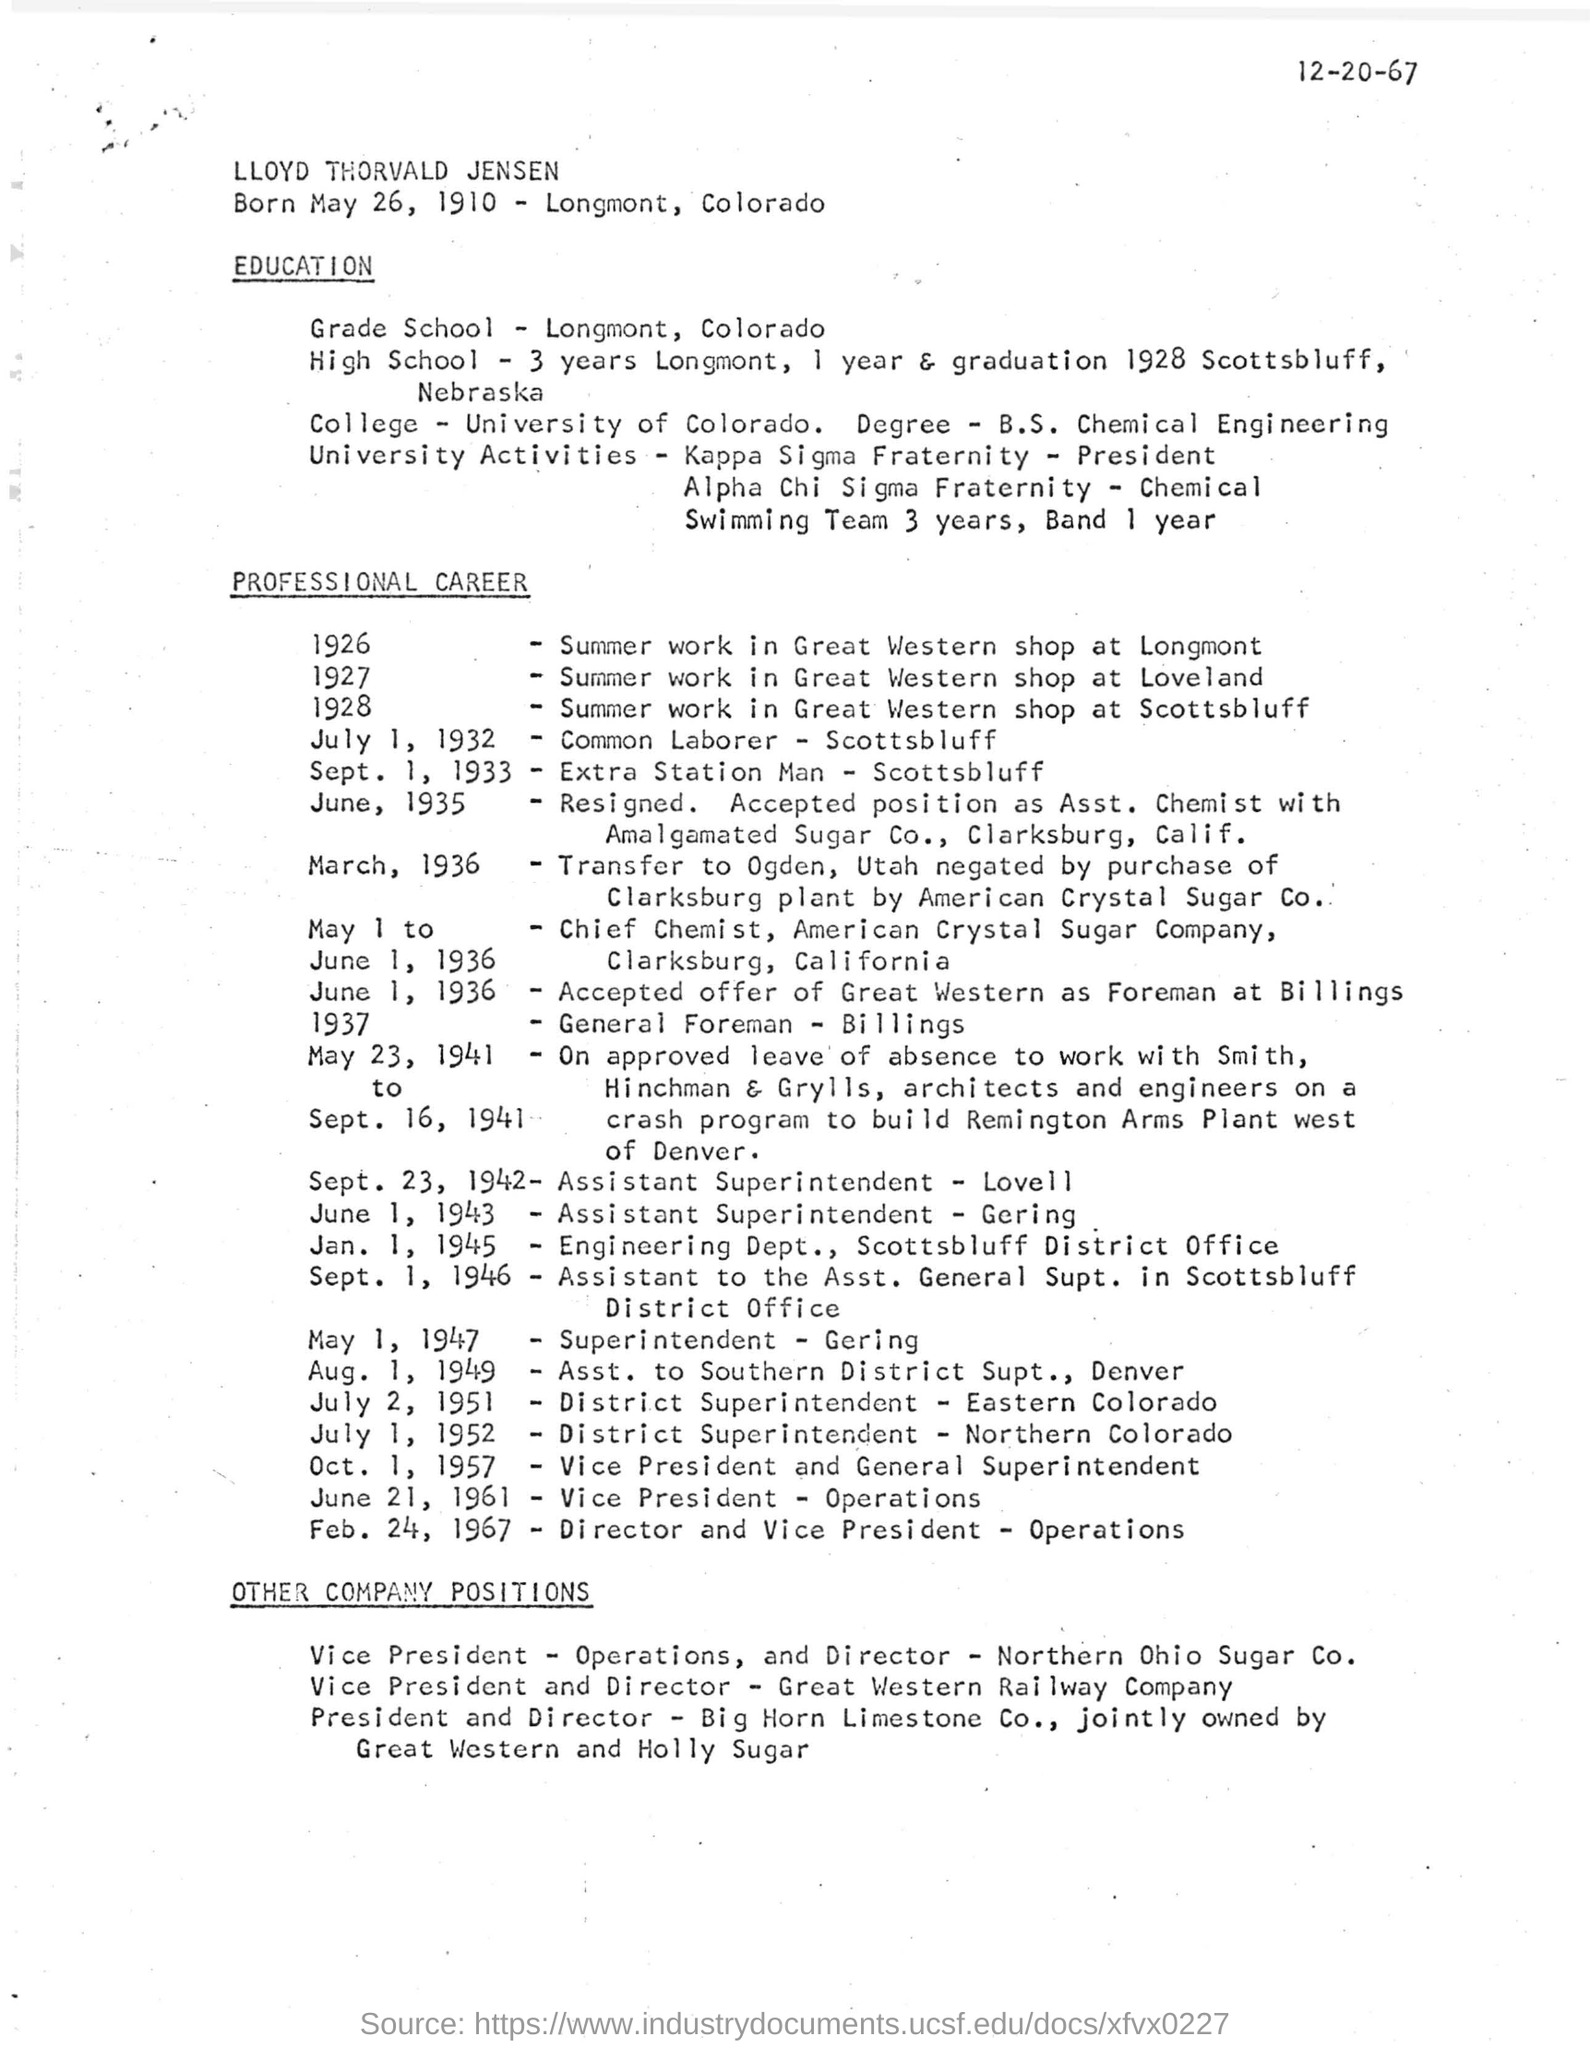Indicate a few pertinent items in this graphic. Lloyd Thorvald Jensen was born on May 26, 1910. 